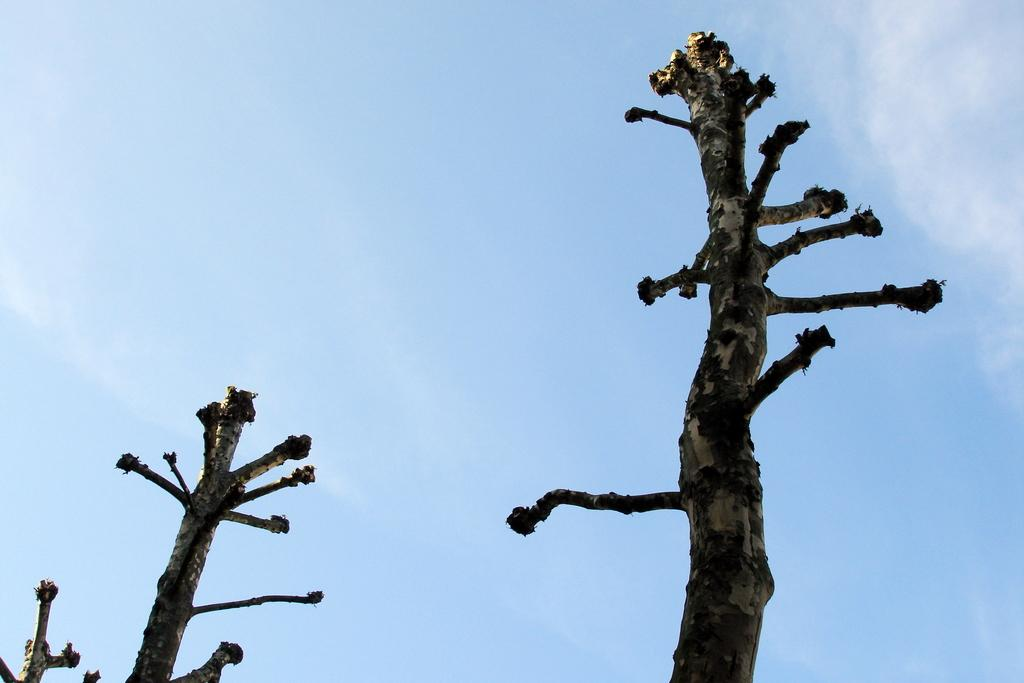What type of vegetation can be seen in the image? There are branches of trees in the image. What part of the natural environment is visible in the image? The sky is visible in the background of the image. What type of snack is being shared by the women in the image? There are no women or snacks present in the image; it only features branches of trees and the sky. 